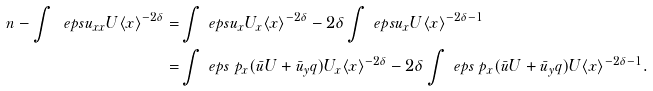Convert formula to latex. <formula><loc_0><loc_0><loc_500><loc_500>\ n - \int \ e p s u _ { x x } U \langle x \rangle ^ { - 2 \delta } = & \int \ e p s u _ { x } U _ { x } \langle x \rangle ^ { - 2 \delta } - 2 \delta \int \ e p s u _ { x } U \langle x \rangle ^ { - 2 \delta - 1 } \\ = & \int \ e p s \ p _ { x } ( \bar { u } U + \bar { u } _ { y } q ) U _ { x } \langle x \rangle ^ { - 2 \delta } - 2 \delta \int \ e p s \ p _ { x } ( \bar { u } U + \bar { u } _ { y } q ) U \langle x \rangle ^ { - 2 \delta - 1 } .</formula> 